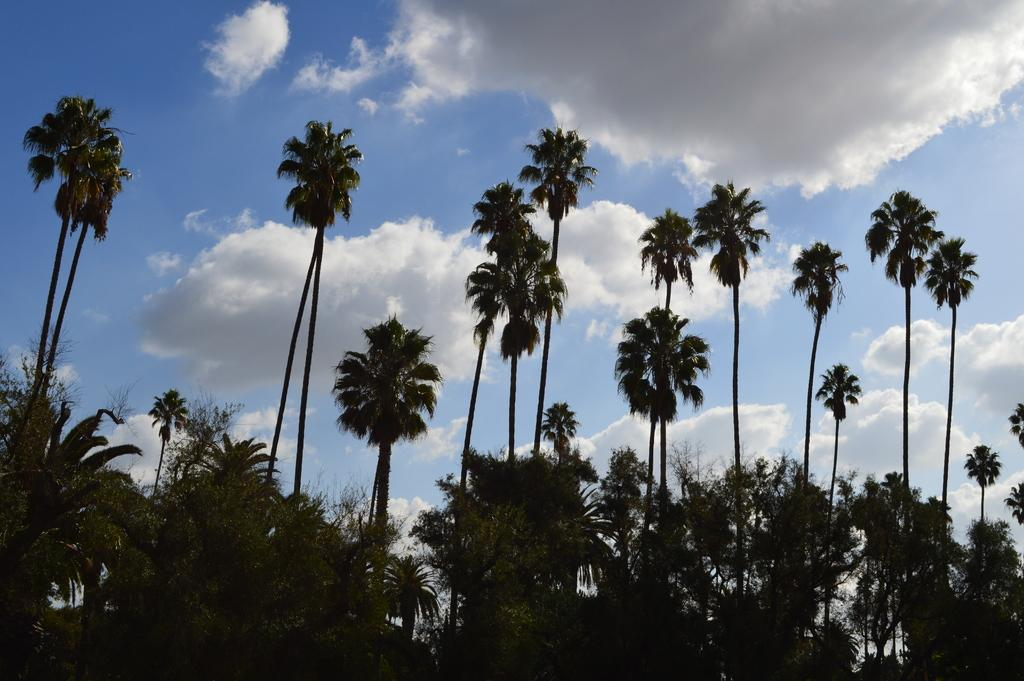What type of vegetation can be seen in the image? There are trees in the image. What is visible in the background of the image? The sky is visible in the background of the image. What can be observed in the sky? Clouds are present in the sky. What mark can be seen on the tree in the image? There is no specific mark mentioned on any tree in the image. What type of watch is visible on the tree in the image? There is no watch present on any tree in the image. 